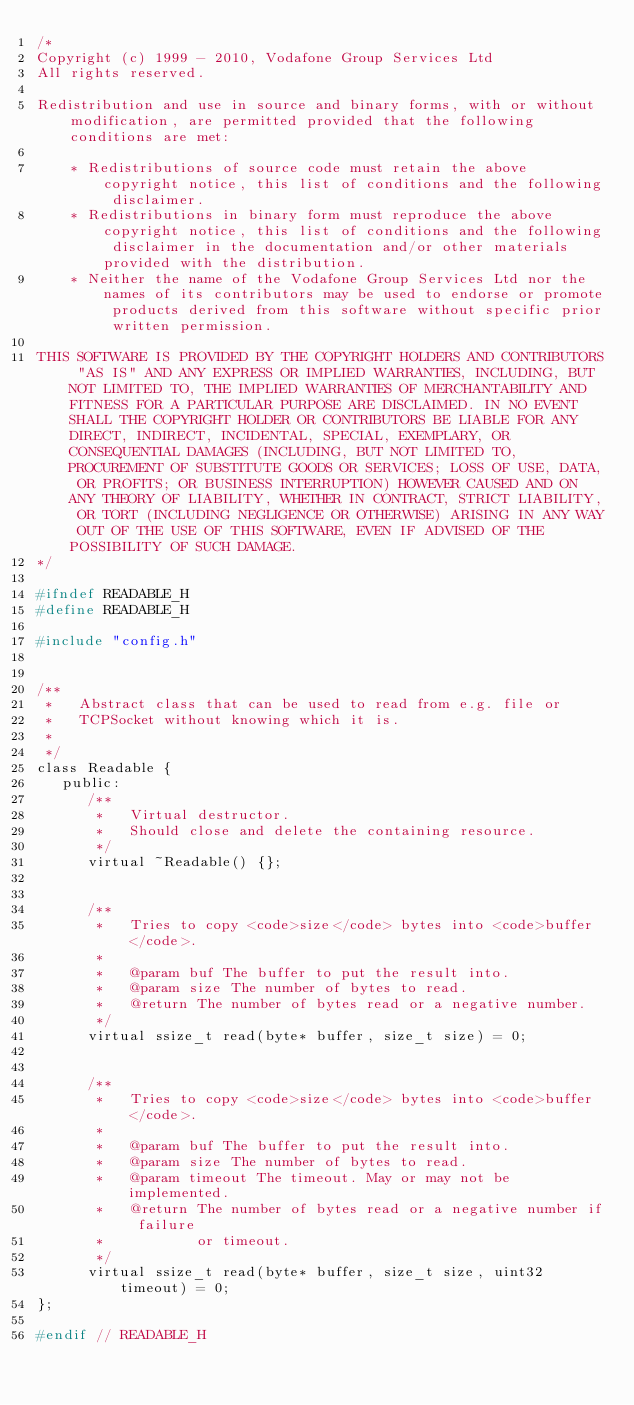<code> <loc_0><loc_0><loc_500><loc_500><_C_>/*
Copyright (c) 1999 - 2010, Vodafone Group Services Ltd
All rights reserved.

Redistribution and use in source and binary forms, with or without modification, are permitted provided that the following conditions are met:

    * Redistributions of source code must retain the above copyright notice, this list of conditions and the following disclaimer.
    * Redistributions in binary form must reproduce the above copyright notice, this list of conditions and the following disclaimer in the documentation and/or other materials provided with the distribution.
    * Neither the name of the Vodafone Group Services Ltd nor the names of its contributors may be used to endorse or promote products derived from this software without specific prior written permission.

THIS SOFTWARE IS PROVIDED BY THE COPYRIGHT HOLDERS AND CONTRIBUTORS "AS IS" AND ANY EXPRESS OR IMPLIED WARRANTIES, INCLUDING, BUT NOT LIMITED TO, THE IMPLIED WARRANTIES OF MERCHANTABILITY AND FITNESS FOR A PARTICULAR PURPOSE ARE DISCLAIMED. IN NO EVENT SHALL THE COPYRIGHT HOLDER OR CONTRIBUTORS BE LIABLE FOR ANY DIRECT, INDIRECT, INCIDENTAL, SPECIAL, EXEMPLARY, OR CONSEQUENTIAL DAMAGES (INCLUDING, BUT NOT LIMITED TO, PROCUREMENT OF SUBSTITUTE GOODS OR SERVICES; LOSS OF USE, DATA, OR PROFITS; OR BUSINESS INTERRUPTION) HOWEVER CAUSED AND ON ANY THEORY OF LIABILITY, WHETHER IN CONTRACT, STRICT LIABILITY, OR TORT (INCLUDING NEGLIGENCE OR OTHERWISE) ARISING IN ANY WAY OUT OF THE USE OF THIS SOFTWARE, EVEN IF ADVISED OF THE POSSIBILITY OF SUCH DAMAGE.
*/

#ifndef READABLE_H
#define READABLE_H

#include "config.h"


/**
 *   Abstract class that can be used to read from e.g. file or
 *   TCPSocket without knowing which it is.
 *
 */
class Readable {
   public:
      /**
       *   Virtual destructor.
       *   Should close and delete the containing resource.
       */
      virtual ~Readable() {};
   

      /**
       *   Tries to copy <code>size</code> bytes into <code>buffer</code>.
       *
       *   @param buf The buffer to put the result into.
       *   @param size The number of bytes to read.
       *   @return The number of bytes read or a negative number.
       */
      virtual ssize_t read(byte* buffer, size_t size) = 0;


      /**
       *   Tries to copy <code>size</code> bytes into <code>buffer</code>.
       *
       *   @param buf The buffer to put the result into.
       *   @param size The number of bytes to read.
       *   @param timeout The timeout. May or may not be implemented.
       *   @return The number of bytes read or a negative number if failure
       *           or timeout.
       */
      virtual ssize_t read(byte* buffer, size_t size, uint32 timeout) = 0;
};

#endif // READABLE_H

</code> 